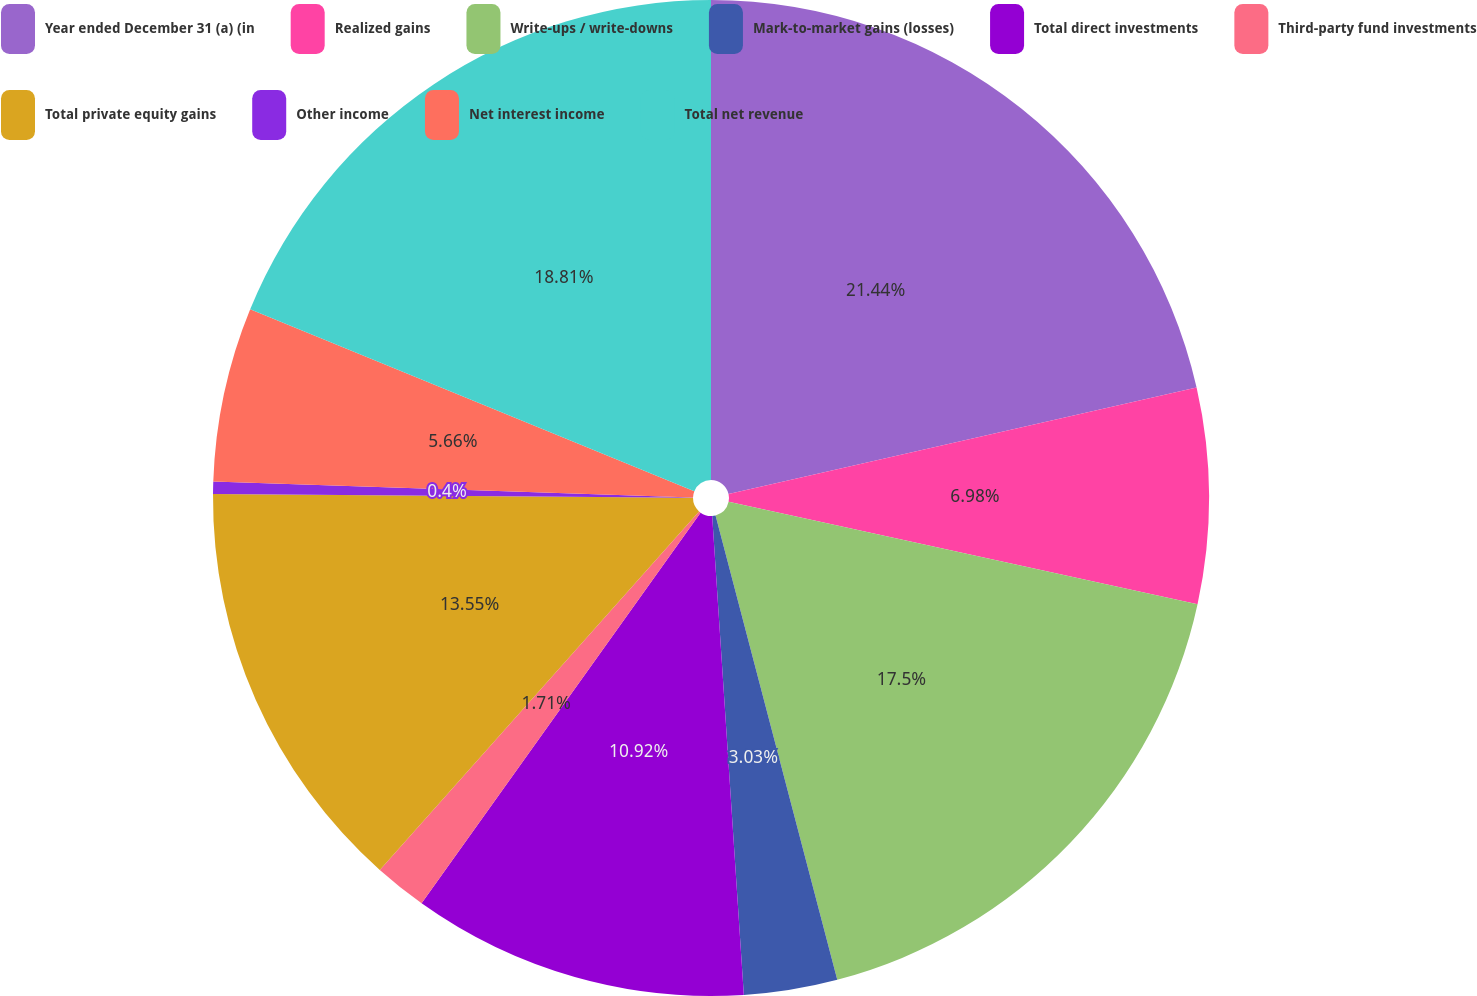Convert chart. <chart><loc_0><loc_0><loc_500><loc_500><pie_chart><fcel>Year ended December 31 (a) (in<fcel>Realized gains<fcel>Write-ups / write-downs<fcel>Mark-to-market gains (losses)<fcel>Total direct investments<fcel>Third-party fund investments<fcel>Total private equity gains<fcel>Other income<fcel>Net interest income<fcel>Total net revenue<nl><fcel>21.44%<fcel>6.98%<fcel>17.5%<fcel>3.03%<fcel>10.92%<fcel>1.71%<fcel>13.55%<fcel>0.4%<fcel>5.66%<fcel>18.81%<nl></chart> 